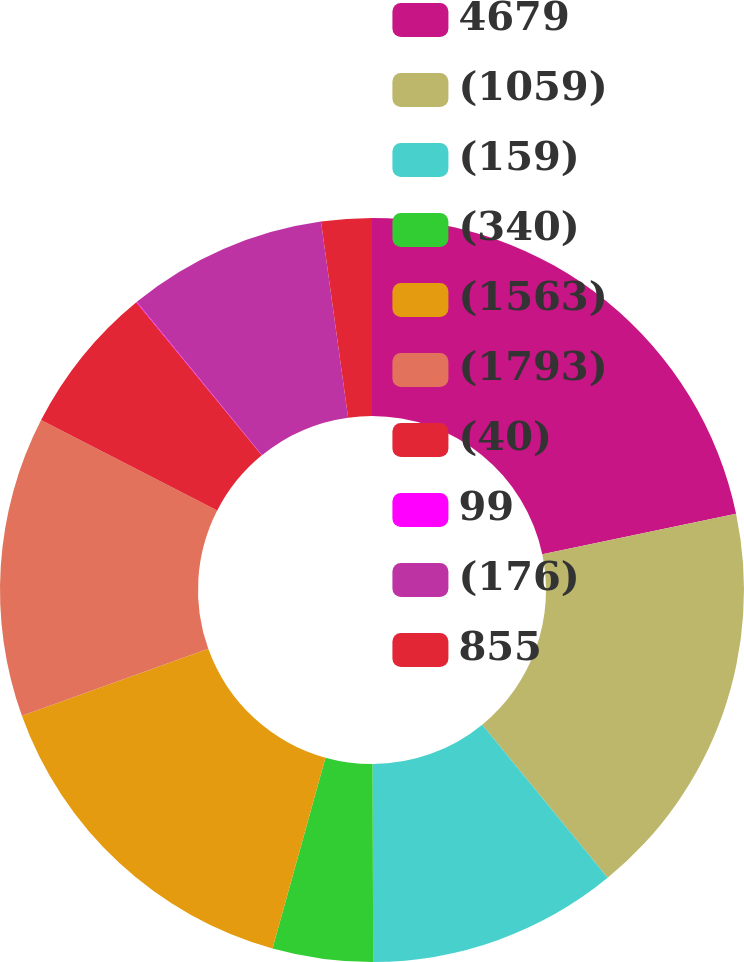<chart> <loc_0><loc_0><loc_500><loc_500><pie_chart><fcel>4679<fcel>(1059)<fcel>(159)<fcel>(340)<fcel>(1563)<fcel>(1793)<fcel>(40)<fcel>99<fcel>(176)<fcel>855<nl><fcel>21.71%<fcel>17.37%<fcel>10.87%<fcel>4.36%<fcel>15.2%<fcel>13.04%<fcel>6.53%<fcel>0.03%<fcel>8.7%<fcel>2.19%<nl></chart> 